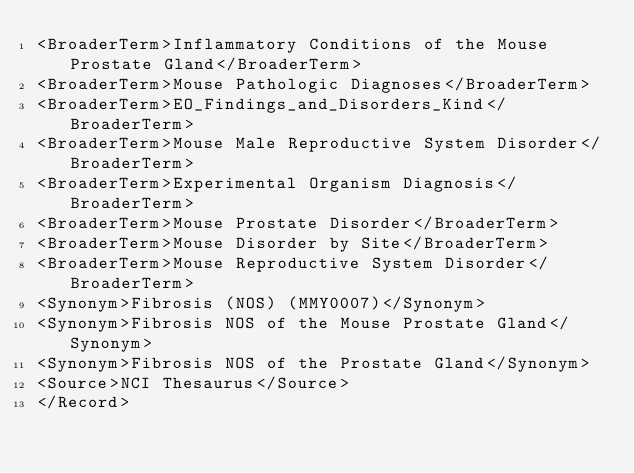<code> <loc_0><loc_0><loc_500><loc_500><_XML_><BroaderTerm>Inflammatory Conditions of the Mouse Prostate Gland</BroaderTerm>
<BroaderTerm>Mouse Pathologic Diagnoses</BroaderTerm>
<BroaderTerm>EO_Findings_and_Disorders_Kind</BroaderTerm>
<BroaderTerm>Mouse Male Reproductive System Disorder</BroaderTerm>
<BroaderTerm>Experimental Organism Diagnosis</BroaderTerm>
<BroaderTerm>Mouse Prostate Disorder</BroaderTerm>
<BroaderTerm>Mouse Disorder by Site</BroaderTerm>
<BroaderTerm>Mouse Reproductive System Disorder</BroaderTerm>
<Synonym>Fibrosis (NOS) (MMY0007)</Synonym>
<Synonym>Fibrosis NOS of the Mouse Prostate Gland</Synonym>
<Synonym>Fibrosis NOS of the Prostate Gland</Synonym>
<Source>NCI Thesaurus</Source>
</Record>
</code> 